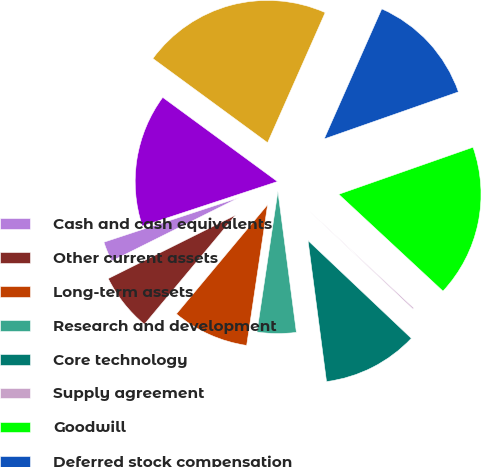Convert chart to OTSL. <chart><loc_0><loc_0><loc_500><loc_500><pie_chart><fcel>Cash and cash equivalents<fcel>Other current assets<fcel>Long-term assets<fcel>Research and development<fcel>Core technology<fcel>Supply agreement<fcel>Goodwill<fcel>Deferred stock compensation<fcel>Total assets acquired<fcel>Current liabilities<nl><fcel>2.29%<fcel>6.57%<fcel>8.72%<fcel>4.43%<fcel>10.86%<fcel>0.15%<fcel>17.28%<fcel>13.0%<fcel>21.56%<fcel>15.14%<nl></chart> 